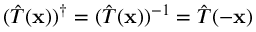<formula> <loc_0><loc_0><loc_500><loc_500>( { \hat { T } } ( x ) ) ^ { \dagger } = ( { \hat { T } } ( x ) ) ^ { - 1 } = { \hat { T } } ( - x )</formula> 